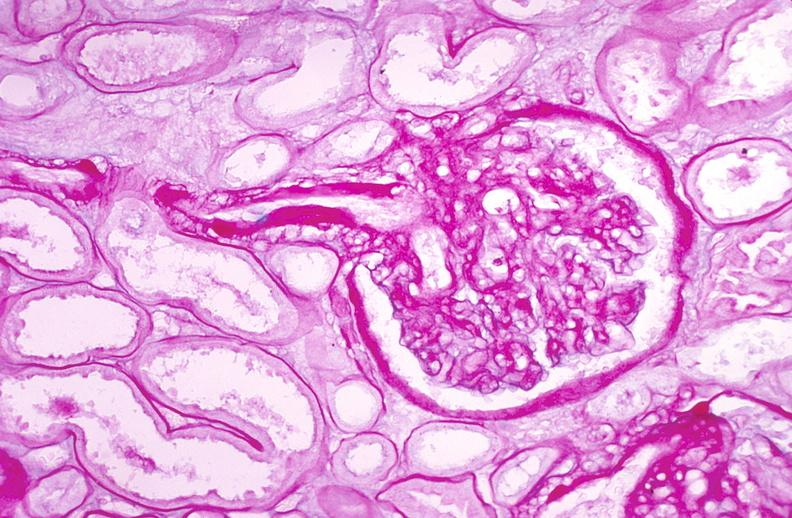what does this image show?
Answer the question using a single word or phrase. Kidney glomerulus 